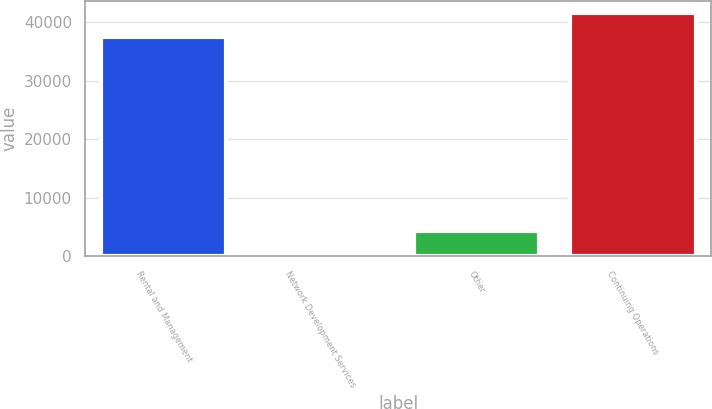Convert chart. <chart><loc_0><loc_0><loc_500><loc_500><bar_chart><fcel>Rental and Management<fcel>Network Development Services<fcel>Other<fcel>Continuing Operations<nl><fcel>37453<fcel>290<fcel>4412.1<fcel>41575.1<nl></chart> 